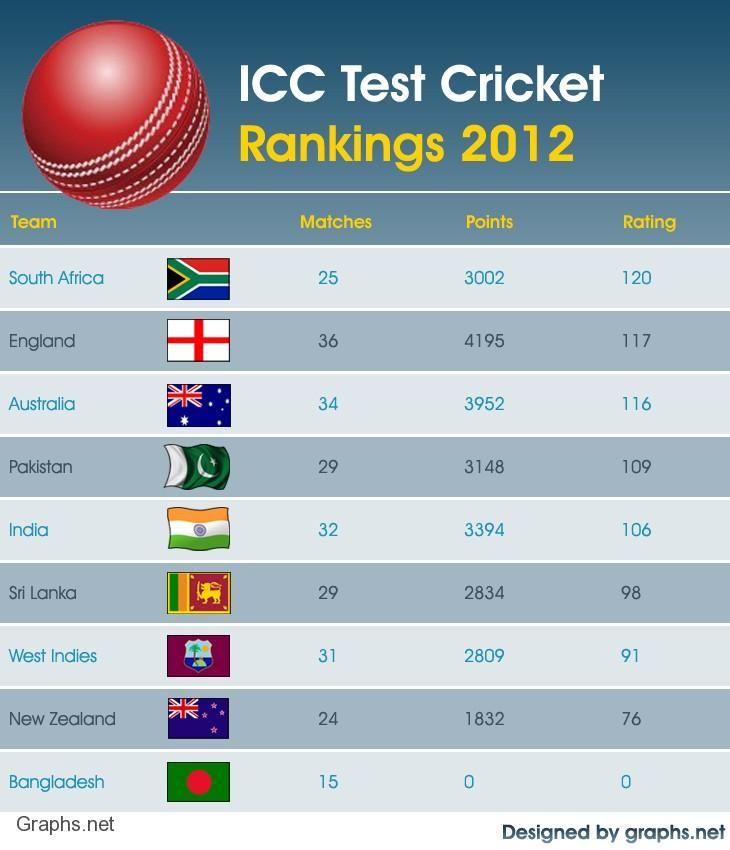Which cricket team has the lowest ICC test cricket rating in 2012?
Answer the question with a short phrase. Bangladesh Which team scored the highest number of test match points in 2012? England How many test cricket matches were played by England in 2012? 36 Which team scored the least number of test match points in 2012? Bangladesh How many test cricket matches were played by West Indies in 2012? 31 Which cricket team has the highest ICC test cricket rating in 2012? South Africa How many test cricket matches were played by India in 2012? 32 Which cricket team has the second-lowest ICC test cricket rating in 2012? New Zealand Which cricket team has the second highest ICC test cricket rating in 2012? England Which team played the highest number of test matches in 2012? England 